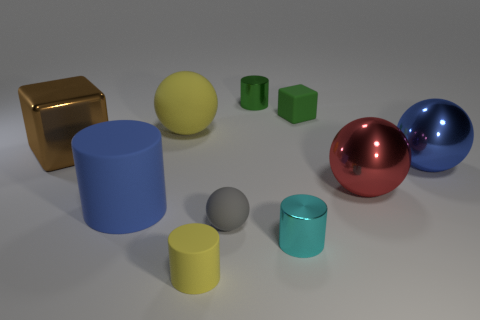How is the lighting in the scene affecting the appearance of the objects? The lighting in the scene is casting soft shadows and highlights on the objects, enhancing their three-dimensional forms. The reflective objects, like the brown block and the spheres, are picking up strong highlights and show reflections of their surroundings, which emphasizes their shiny surfaces. The matte objects have more diffused highlights, which show their colors consistently with less reflection. 